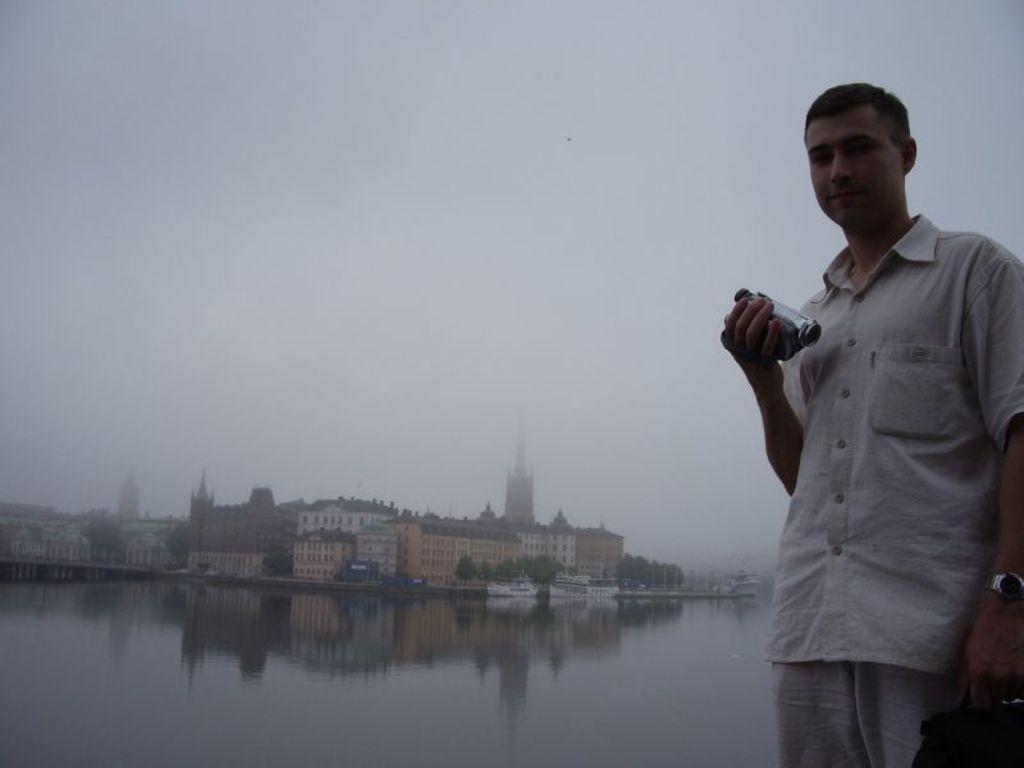In one or two sentences, can you explain what this image depicts? On the left side of the image there is a person standing and holding a camera in one hand and on the other hand he is holding a bag, behind him there is a river and there is a ship on the river. At the center of the image there are buildings. In the background there is a sky. 